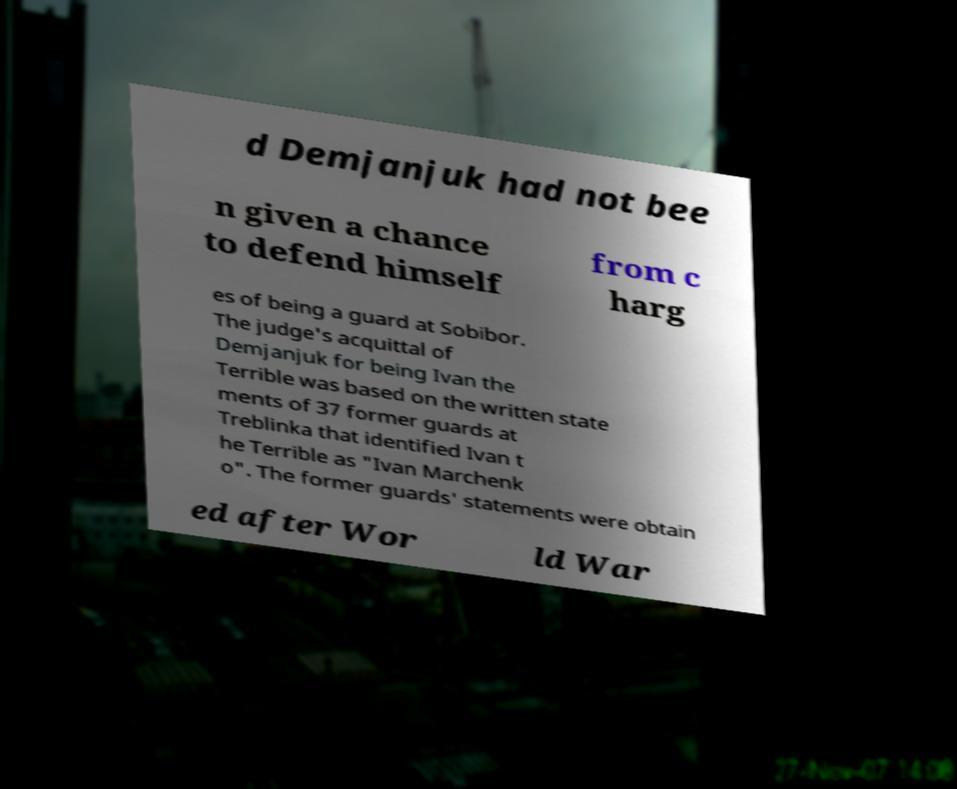Can you read and provide the text displayed in the image?This photo seems to have some interesting text. Can you extract and type it out for me? d Demjanjuk had not bee n given a chance to defend himself from c harg es of being a guard at Sobibor. The judge's acquittal of Demjanjuk for being Ivan the Terrible was based on the written state ments of 37 former guards at Treblinka that identified Ivan t he Terrible as "Ivan Marchenk o". The former guards' statements were obtain ed after Wor ld War 